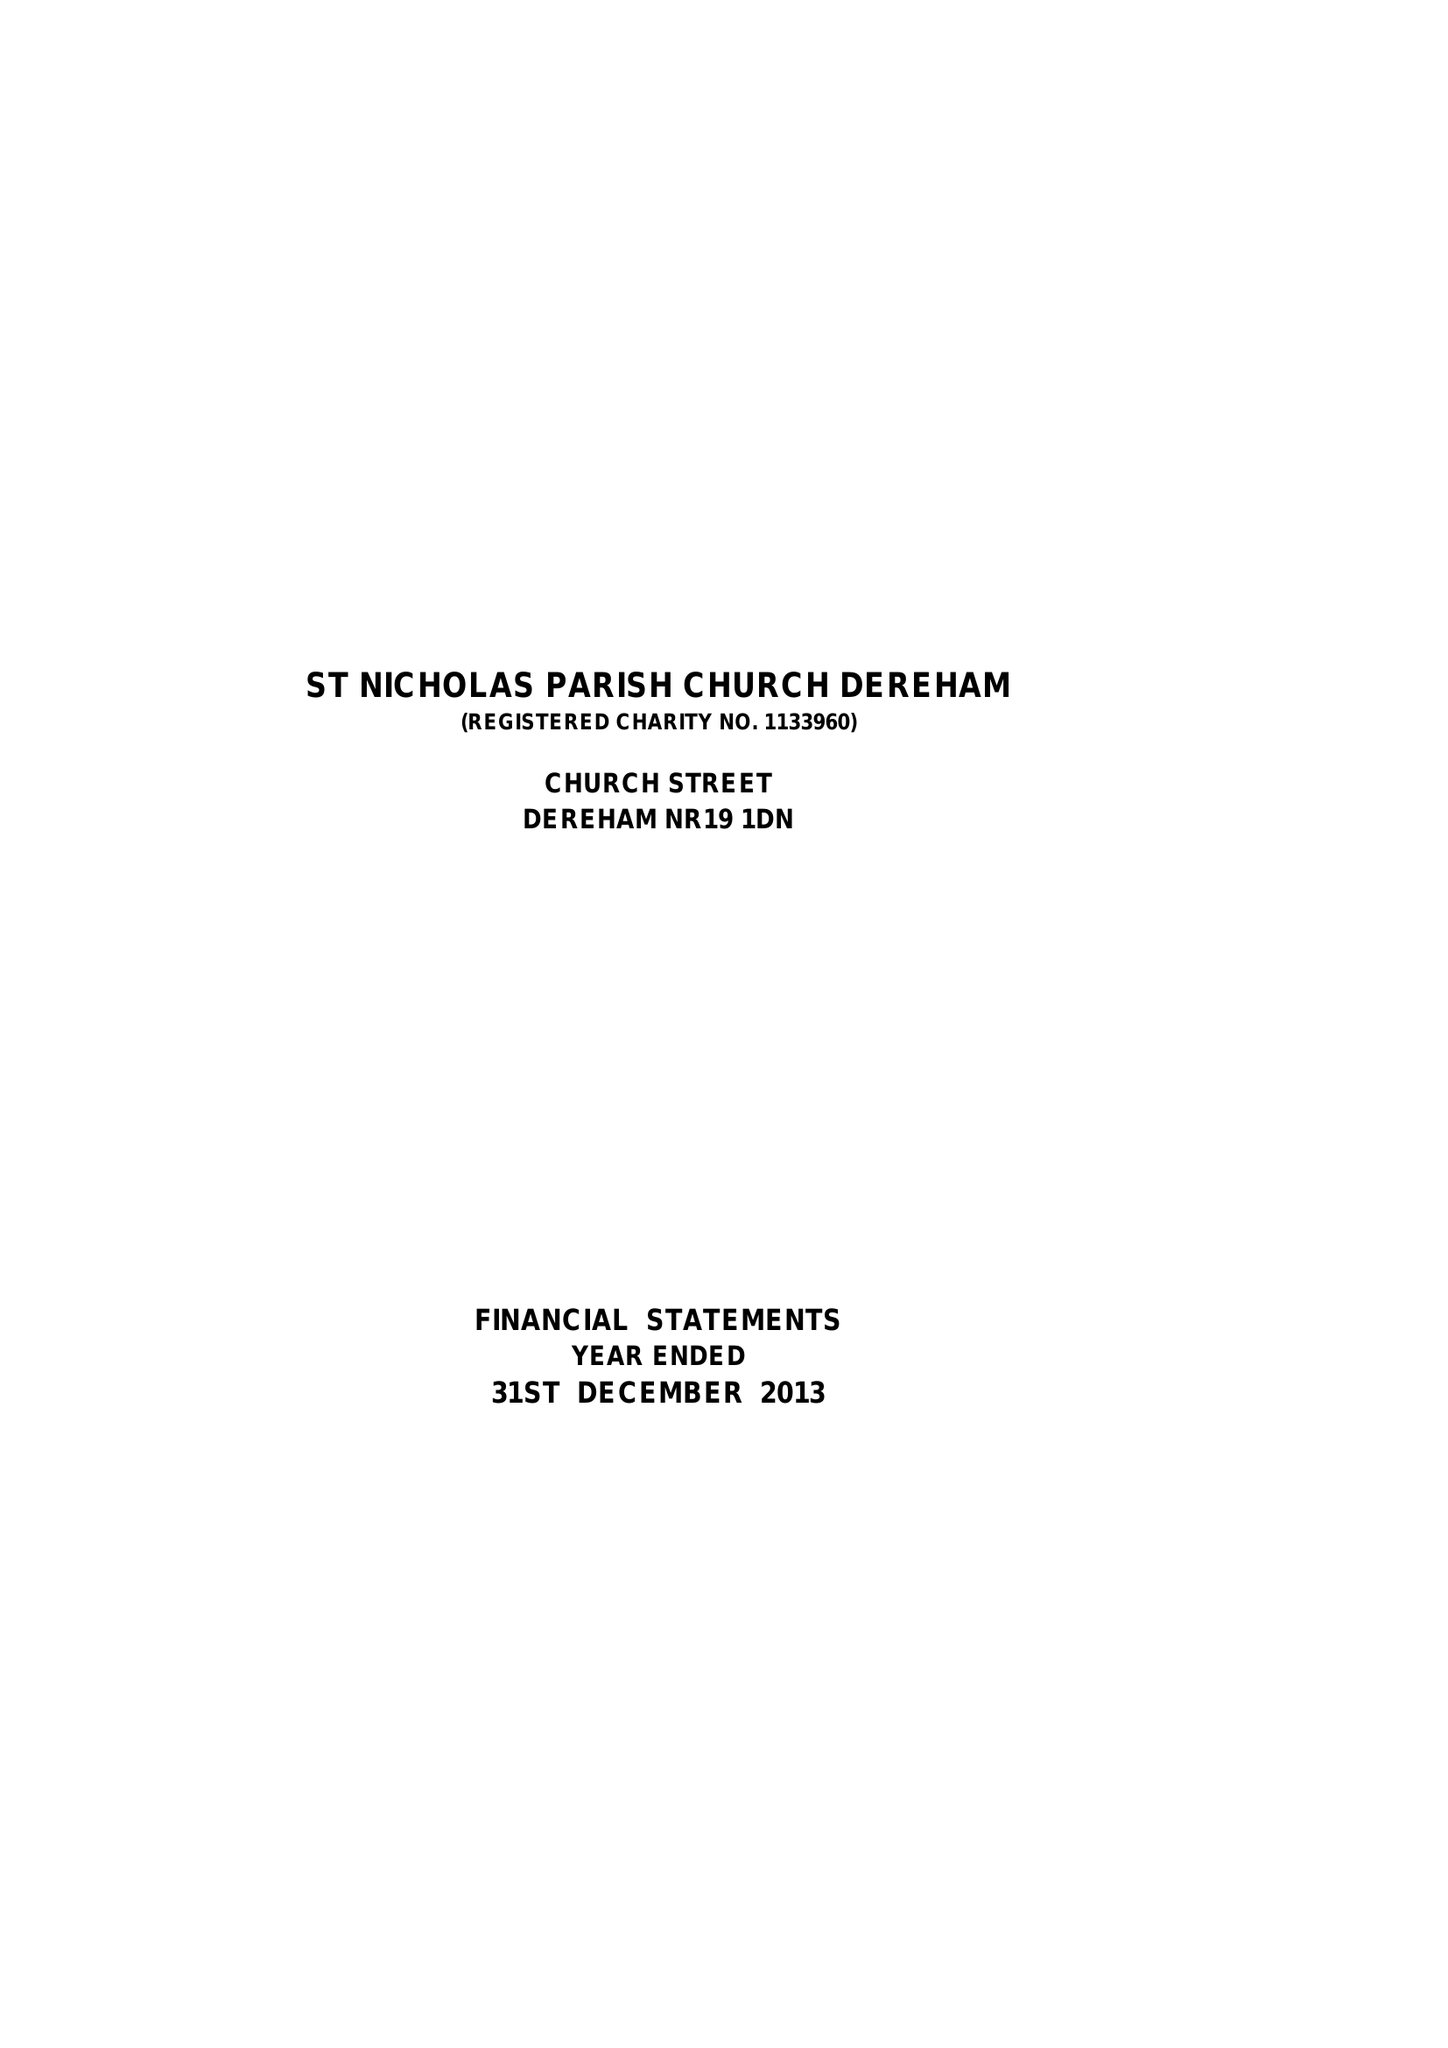What is the value for the income_annually_in_british_pounds?
Answer the question using a single word or phrase. 135758.00 